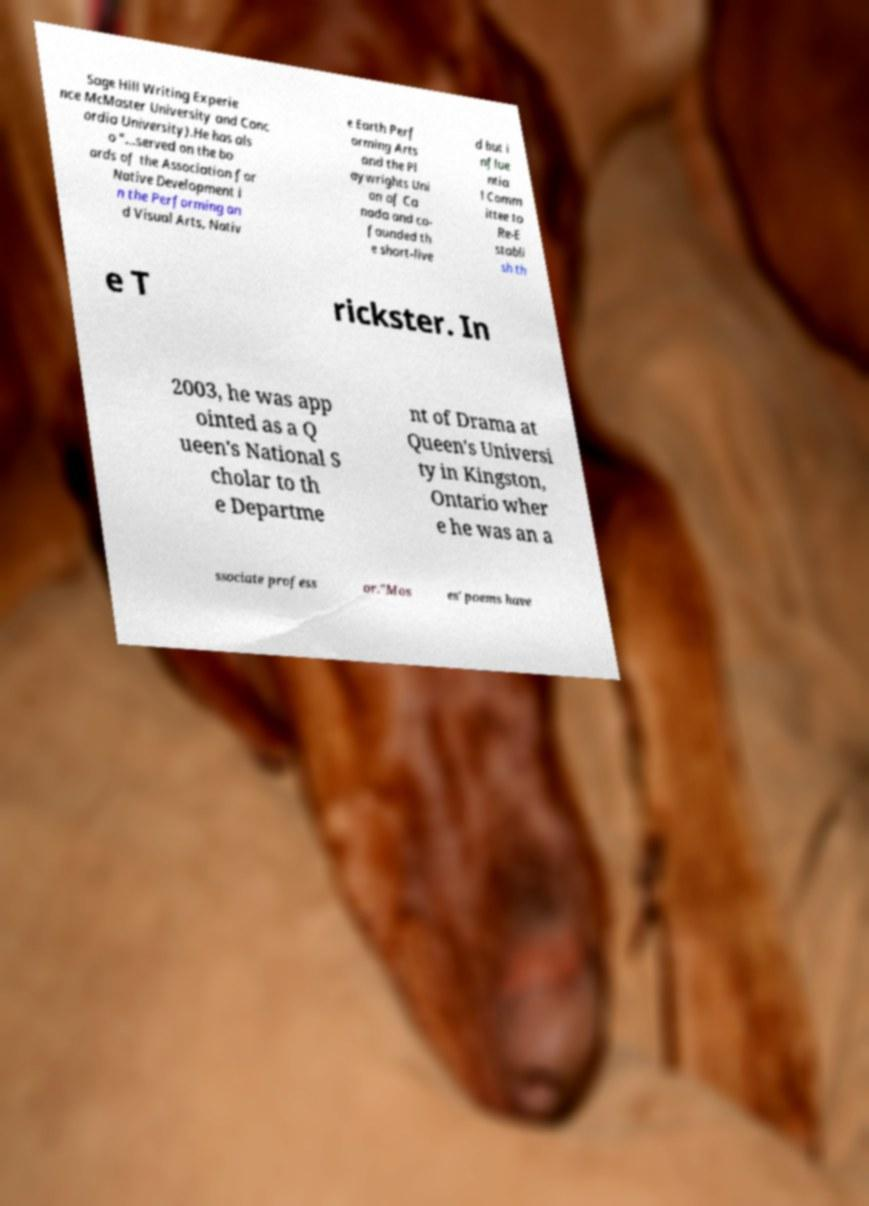What messages or text are displayed in this image? I need them in a readable, typed format. Sage Hill Writing Experie nce McMaster University and Conc ordia University).He has als o "...served on the bo ards of the Association for Native Development i n the Performing an d Visual Arts, Nativ e Earth Perf orming Arts and the Pl aywrights Uni on of Ca nada and co- founded th e short-live d but i nflue ntia l Comm ittee to Re-E stabli sh th e T rickster. In 2003, he was app ointed as a Q ueen's National S cholar to th e Departme nt of Drama at Queen's Universi ty in Kingston, Ontario wher e he was an a ssociate profess or."Mos es' poems have 